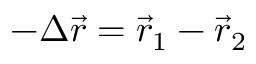Convert formula to latex. <formula><loc_0><loc_0><loc_500><loc_500>- \Delta \vec { r } = \vec { r } _ { 1 } - \vec { r } _ { 2 }</formula> 